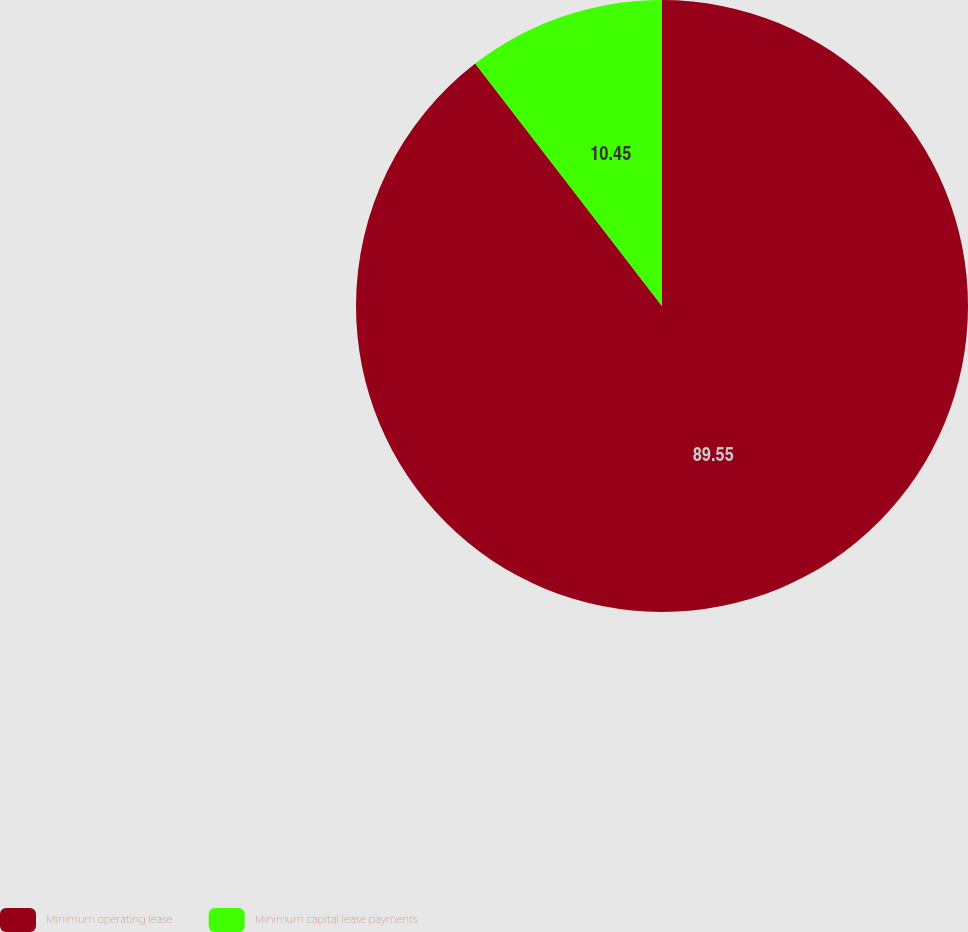Convert chart to OTSL. <chart><loc_0><loc_0><loc_500><loc_500><pie_chart><fcel>Minimum operating lease<fcel>Minimum capital lease payments<nl><fcel>89.55%<fcel>10.45%<nl></chart> 